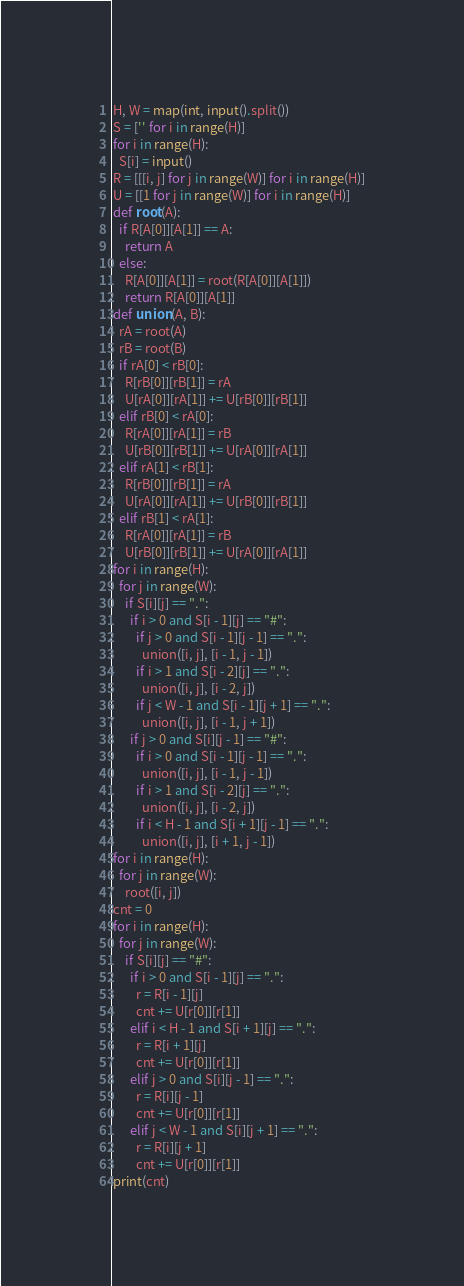Convert code to text. <code><loc_0><loc_0><loc_500><loc_500><_Python_>H, W = map(int, input().split())
S = ['' for i in range(H)]
for i in range(H):
  S[i] = input()
R = [[[i, j] for j in range(W)] for i in range(H)]
U = [[1 for j in range(W)] for i in range(H)]
def root(A):
  if R[A[0]][A[1]] == A:
    return A
  else:
    R[A[0]][A[1]] = root(R[A[0]][A[1]])
    return R[A[0]][A[1]]
def union(A, B):
  rA = root(A)
  rB = root(B)
  if rA[0] < rB[0]:
    R[rB[0]][rB[1]] = rA
    U[rA[0]][rA[1]] += U[rB[0]][rB[1]]
  elif rB[0] < rA[0]:
    R[rA[0]][rA[1]] = rB
    U[rB[0]][rB[1]] += U[rA[0]][rA[1]]
  elif rA[1] < rB[1]:
    R[rB[0]][rB[1]] = rA
    U[rA[0]][rA[1]] += U[rB[0]][rB[1]]
  elif rB[1] < rA[1]:
    R[rA[0]][rA[1]] = rB
    U[rB[0]][rB[1]] += U[rA[0]][rA[1]]
for i in range(H):
  for j in range(W):
    if S[i][j] == ".":
      if i > 0 and S[i - 1][j] == "#":
        if j > 0 and S[i - 1][j - 1] == ".":
          union([i, j], [i - 1, j - 1])
        if i > 1 and S[i - 2][j] == ".":
          union([i, j], [i - 2, j])
        if j < W - 1 and S[i - 1][j + 1] == ".":
          union([i, j], [i - 1, j + 1])
      if j > 0 and S[i][j - 1] == "#":
        if i > 0 and S[i - 1][j - 1] == ".":
          union([i, j], [i - 1, j - 1])
        if i > 1 and S[i - 2][j] == ".":
          union([i, j], [i - 2, j])
        if i < H - 1 and S[i + 1][j - 1] == ".":
          union([i, j], [i + 1, j - 1])
for i in range(H):
  for j in range(W):
    root([i, j])
cnt = 0
for i in range(H):
  for j in range(W):
    if S[i][j] == "#":
      if i > 0 and S[i - 1][j] == ".":
        r = R[i - 1][j]
        cnt += U[r[0]][r[1]]
      elif i < H - 1 and S[i + 1][j] == ".":
        r = R[i + 1][j]
        cnt += U[r[0]][r[1]]
      elif j > 0 and S[i][j - 1] == ".":
        r = R[i][j - 1]
        cnt += U[r[0]][r[1]]
      elif j < W - 1 and S[i][j + 1] == ".":
        r = R[i][j + 1]
        cnt += U[r[0]][r[1]]
print(cnt)</code> 